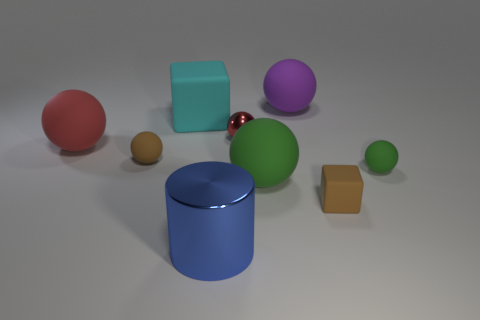What could the arrangement of these objects represent or symbolize? The arrangement of these geometric shapes might symbolize balance and variety. The assortment of shapes and colors could represent diversity and the idea that different elements can coexist harmoniously in a shared space. The spread-out placement of the objects might also evoke a sense of spaciousness and order. 